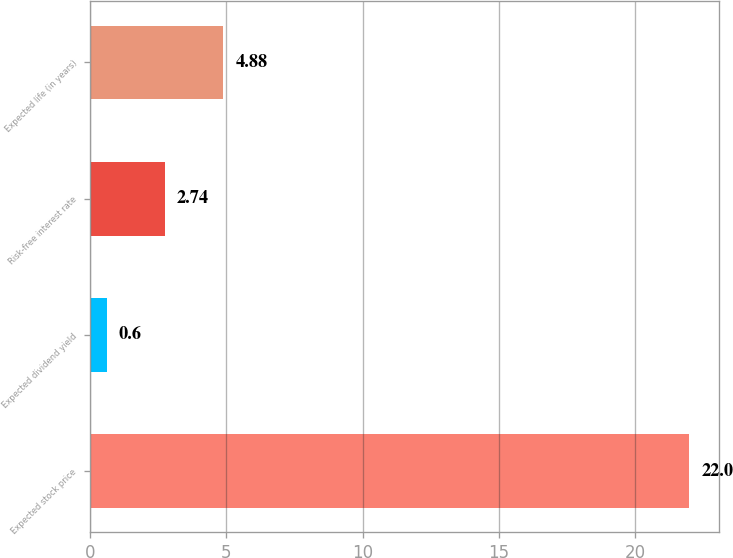Convert chart to OTSL. <chart><loc_0><loc_0><loc_500><loc_500><bar_chart><fcel>Expected stock price<fcel>Expected dividend yield<fcel>Risk-free interest rate<fcel>Expected life (in years)<nl><fcel>22<fcel>0.6<fcel>2.74<fcel>4.88<nl></chart> 